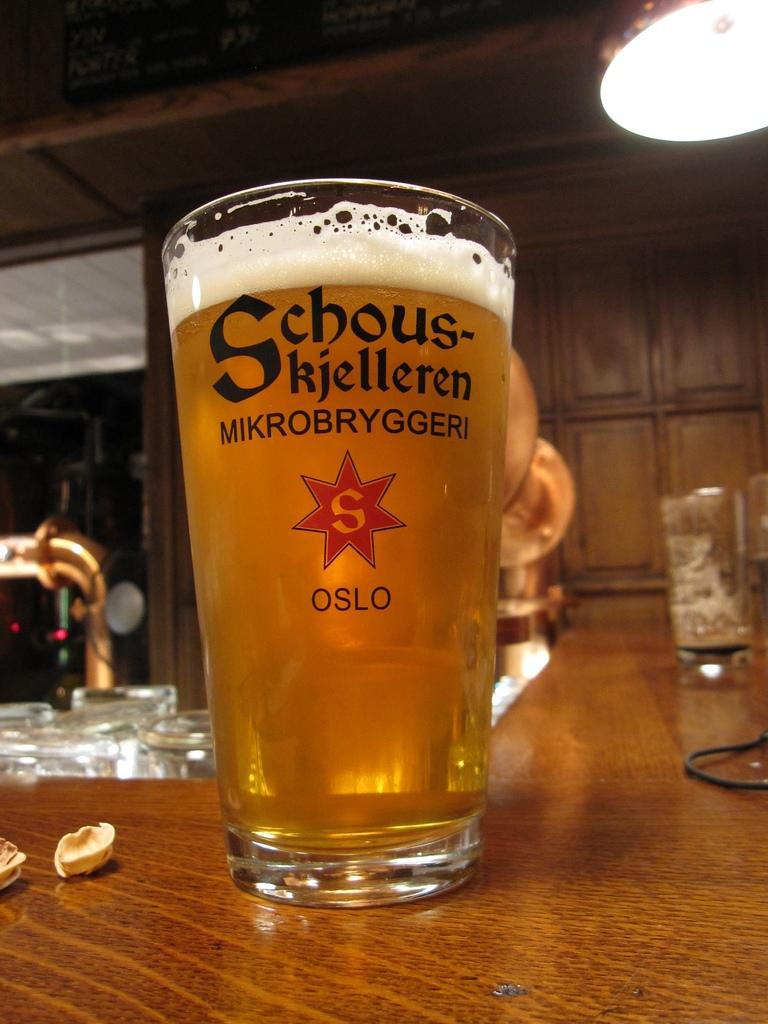<image>
Offer a succinct explanation of the picture presented. A schous-kjelleren glass full of beer on the bar 